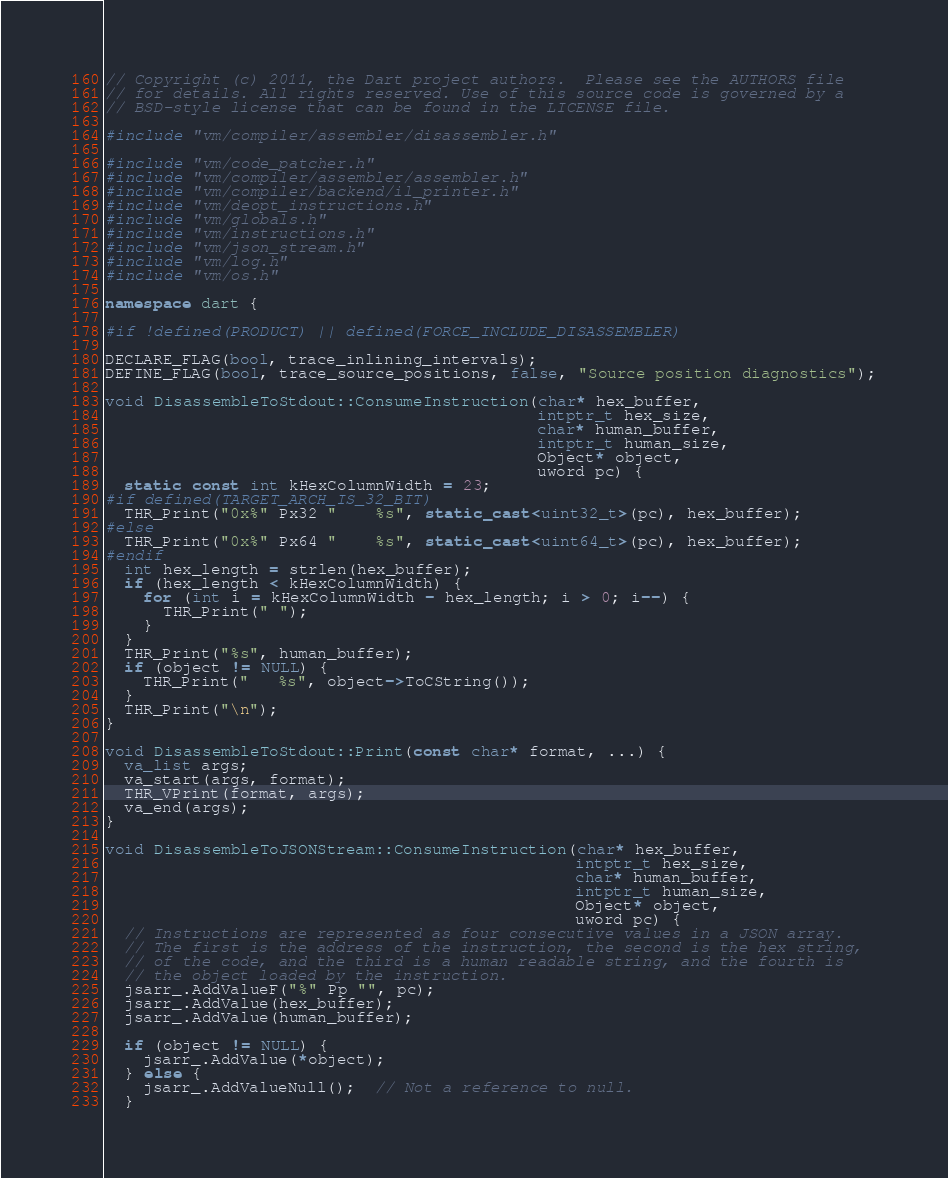<code> <loc_0><loc_0><loc_500><loc_500><_C++_>// Copyright (c) 2011, the Dart project authors.  Please see the AUTHORS file
// for details. All rights reserved. Use of this source code is governed by a
// BSD-style license that can be found in the LICENSE file.

#include "vm/compiler/assembler/disassembler.h"

#include "vm/code_patcher.h"
#include "vm/compiler/assembler/assembler.h"
#include "vm/compiler/backend/il_printer.h"
#include "vm/deopt_instructions.h"
#include "vm/globals.h"
#include "vm/instructions.h"
#include "vm/json_stream.h"
#include "vm/log.h"
#include "vm/os.h"

namespace dart {

#if !defined(PRODUCT) || defined(FORCE_INCLUDE_DISASSEMBLER)

DECLARE_FLAG(bool, trace_inlining_intervals);
DEFINE_FLAG(bool, trace_source_positions, false, "Source position diagnostics");

void DisassembleToStdout::ConsumeInstruction(char* hex_buffer,
                                             intptr_t hex_size,
                                             char* human_buffer,
                                             intptr_t human_size,
                                             Object* object,
                                             uword pc) {
  static const int kHexColumnWidth = 23;
#if defined(TARGET_ARCH_IS_32_BIT)
  THR_Print("0x%" Px32 "    %s", static_cast<uint32_t>(pc), hex_buffer);
#else
  THR_Print("0x%" Px64 "    %s", static_cast<uint64_t>(pc), hex_buffer);
#endif
  int hex_length = strlen(hex_buffer);
  if (hex_length < kHexColumnWidth) {
    for (int i = kHexColumnWidth - hex_length; i > 0; i--) {
      THR_Print(" ");
    }
  }
  THR_Print("%s", human_buffer);
  if (object != NULL) {
    THR_Print("   %s", object->ToCString());
  }
  THR_Print("\n");
}

void DisassembleToStdout::Print(const char* format, ...) {
  va_list args;
  va_start(args, format);
  THR_VPrint(format, args);
  va_end(args);
}

void DisassembleToJSONStream::ConsumeInstruction(char* hex_buffer,
                                                 intptr_t hex_size,
                                                 char* human_buffer,
                                                 intptr_t human_size,
                                                 Object* object,
                                                 uword pc) {
  // Instructions are represented as four consecutive values in a JSON array.
  // The first is the address of the instruction, the second is the hex string,
  // of the code, and the third is a human readable string, and the fourth is
  // the object loaded by the instruction.
  jsarr_.AddValueF("%" Pp "", pc);
  jsarr_.AddValue(hex_buffer);
  jsarr_.AddValue(human_buffer);

  if (object != NULL) {
    jsarr_.AddValue(*object);
  } else {
    jsarr_.AddValueNull();  // Not a reference to null.
  }</code> 